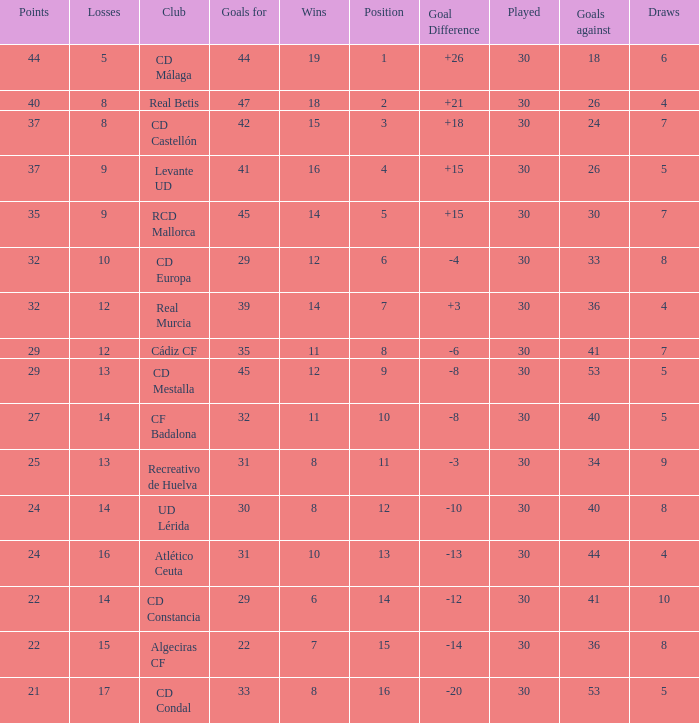What is the goals for when played is larger than 30? None. Give me the full table as a dictionary. {'header': ['Points', 'Losses', 'Club', 'Goals for', 'Wins', 'Position', 'Goal Difference', 'Played', 'Goals against', 'Draws'], 'rows': [['44', '5', 'CD Málaga', '44', '19', '1', '+26', '30', '18', '6'], ['40', '8', 'Real Betis', '47', '18', '2', '+21', '30', '26', '4'], ['37', '8', 'CD Castellón', '42', '15', '3', '+18', '30', '24', '7'], ['37', '9', 'Levante UD', '41', '16', '4', '+15', '30', '26', '5'], ['35', '9', 'RCD Mallorca', '45', '14', '5', '+15', '30', '30', '7'], ['32', '10', 'CD Europa', '29', '12', '6', '-4', '30', '33', '8'], ['32', '12', 'Real Murcia', '39', '14', '7', '+3', '30', '36', '4'], ['29', '12', 'Cádiz CF', '35', '11', '8', '-6', '30', '41', '7'], ['29', '13', 'CD Mestalla', '45', '12', '9', '-8', '30', '53', '5'], ['27', '14', 'CF Badalona', '32', '11', '10', '-8', '30', '40', '5'], ['25', '13', 'Recreativo de Huelva', '31', '8', '11', '-3', '30', '34', '9'], ['24', '14', 'UD Lérida', '30', '8', '12', '-10', '30', '40', '8'], ['24', '16', 'Atlético Ceuta', '31', '10', '13', '-13', '30', '44', '4'], ['22', '14', 'CD Constancia', '29', '6', '14', '-12', '30', '41', '10'], ['22', '15', 'Algeciras CF', '22', '7', '15', '-14', '30', '36', '8'], ['21', '17', 'CD Condal', '33', '8', '16', '-20', '30', '53', '5']]} 